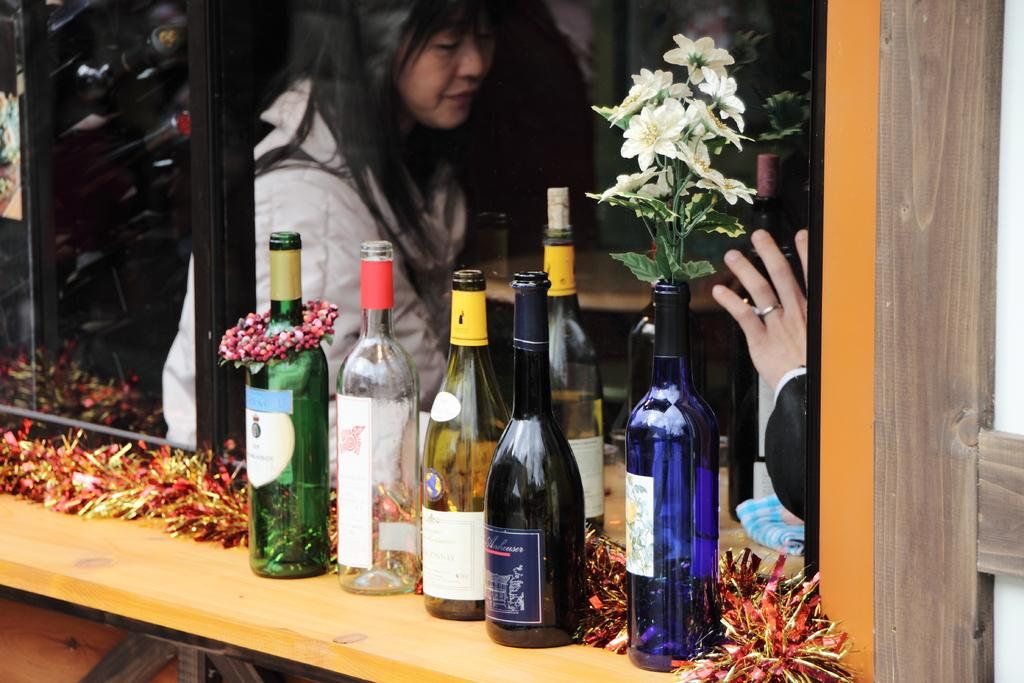What objects are on the table in the image? There are bottles on a table in the image. What is unique about one of the bottles? There is a flower plant inside one of the bottles. Can you describe the woman visible in the image? There is a woman visible through a glass surface in the image. What advertisement can be seen on the table in the image? There is no advertisement present on the table in the image. What type of frog is sitting on the woman's shoulder in the image? There is no frog present in the image, and the woman does not have a frog on her shoulder. 